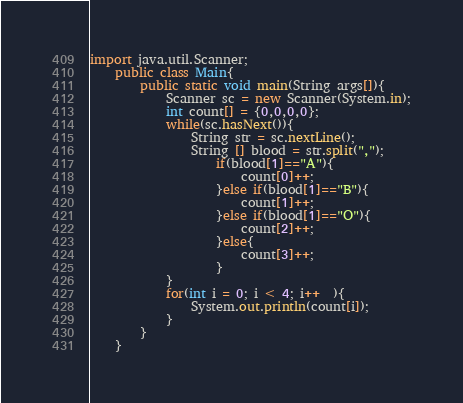<code> <loc_0><loc_0><loc_500><loc_500><_Java_>import java.util.Scanner;
	public class Main{
		public static void main(String args[]){
			Scanner sc = new Scanner(System.in);
			int count[] = {0,0,0,0};
			while(sc.hasNext()){
				String str = sc.nextLine();
				String [] blood = str.split(",");
					if(blood[1]=="A"){
						count[0]++;
					}else if(blood[1]=="B"){
						count[1]++;
					}else if(blood[1]=="O"){
						count[2]++;
					}else{
						count[3]++;
					}
			}
			for(int i = 0; i < 4; i++  ){
				System.out.println(count[i]);
			}
		}
	}		</code> 